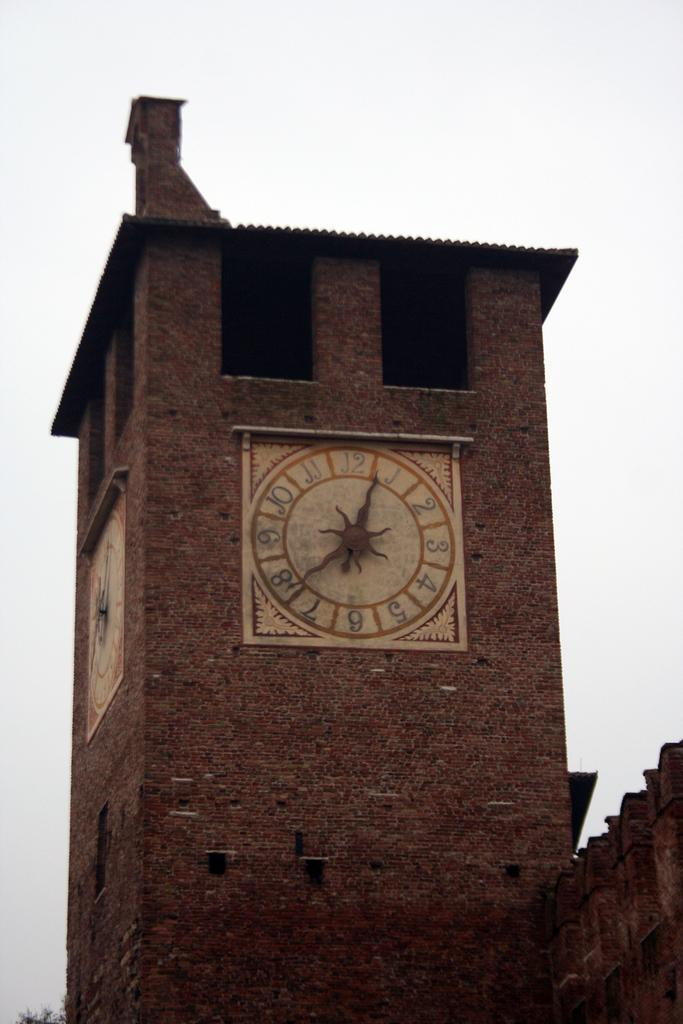<image>
Summarize the visual content of the image. A clock on the side of brick wall points to the numbers 1 and 8 